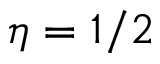Convert formula to latex. <formula><loc_0><loc_0><loc_500><loc_500>\eta = 1 / 2</formula> 